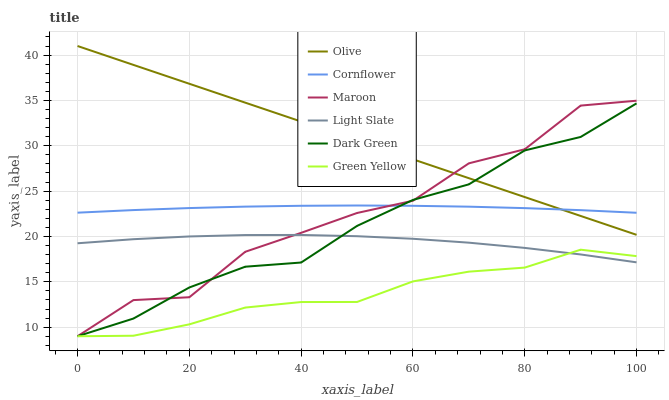Does Light Slate have the minimum area under the curve?
Answer yes or no. No. Does Light Slate have the maximum area under the curve?
Answer yes or no. No. Is Light Slate the smoothest?
Answer yes or no. No. Is Light Slate the roughest?
Answer yes or no. No. Does Light Slate have the lowest value?
Answer yes or no. No. Does Light Slate have the highest value?
Answer yes or no. No. Is Green Yellow less than Olive?
Answer yes or no. Yes. Is Olive greater than Green Yellow?
Answer yes or no. Yes. Does Green Yellow intersect Olive?
Answer yes or no. No. 